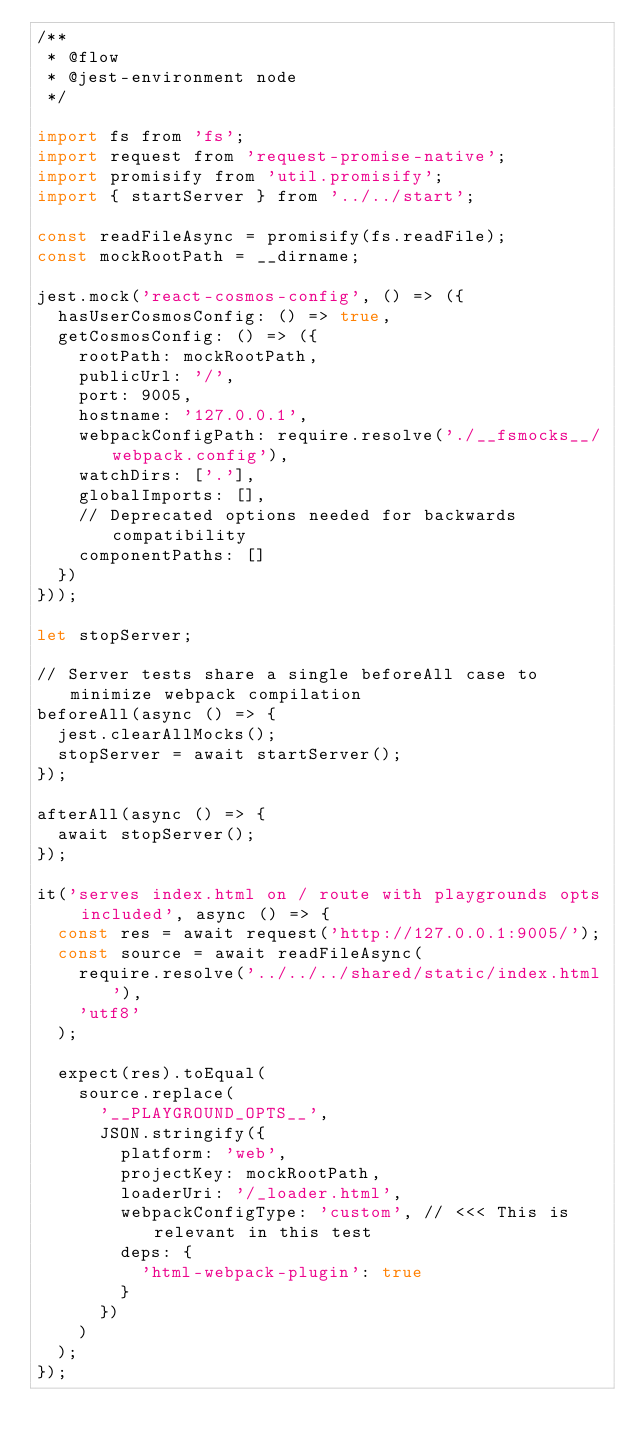Convert code to text. <code><loc_0><loc_0><loc_500><loc_500><_JavaScript_>/**
 * @flow
 * @jest-environment node
 */

import fs from 'fs';
import request from 'request-promise-native';
import promisify from 'util.promisify';
import { startServer } from '../../start';

const readFileAsync = promisify(fs.readFile);
const mockRootPath = __dirname;

jest.mock('react-cosmos-config', () => ({
  hasUserCosmosConfig: () => true,
  getCosmosConfig: () => ({
    rootPath: mockRootPath,
    publicUrl: '/',
    port: 9005,
    hostname: '127.0.0.1',
    webpackConfigPath: require.resolve('./__fsmocks__/webpack.config'),
    watchDirs: ['.'],
    globalImports: [],
    // Deprecated options needed for backwards compatibility
    componentPaths: []
  })
}));

let stopServer;

// Server tests share a single beforeAll case to minimize webpack compilation
beforeAll(async () => {
  jest.clearAllMocks();
  stopServer = await startServer();
});

afterAll(async () => {
  await stopServer();
});

it('serves index.html on / route with playgrounds opts included', async () => {
  const res = await request('http://127.0.0.1:9005/');
  const source = await readFileAsync(
    require.resolve('../../../shared/static/index.html'),
    'utf8'
  );

  expect(res).toEqual(
    source.replace(
      '__PLAYGROUND_OPTS__',
      JSON.stringify({
        platform: 'web',
        projectKey: mockRootPath,
        loaderUri: '/_loader.html',
        webpackConfigType: 'custom', // <<< This is relevant in this test
        deps: {
          'html-webpack-plugin': true
        }
      })
    )
  );
});
</code> 